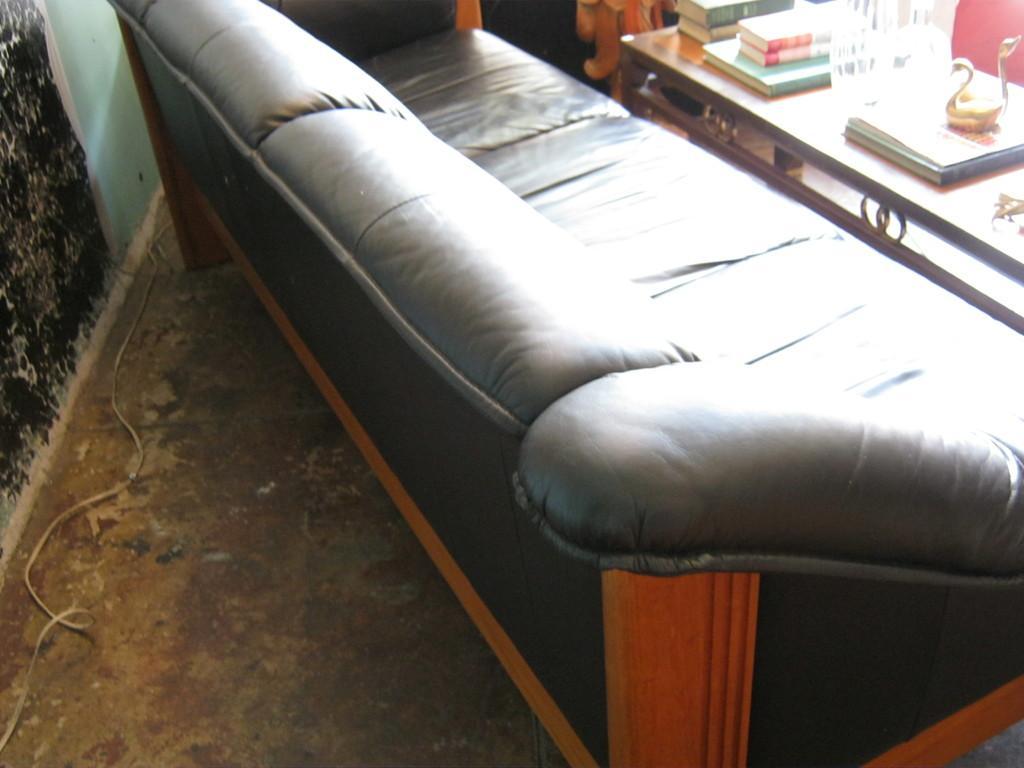Could you give a brief overview of what you see in this image? In the image we can see there is a sofa and on table there are books. 